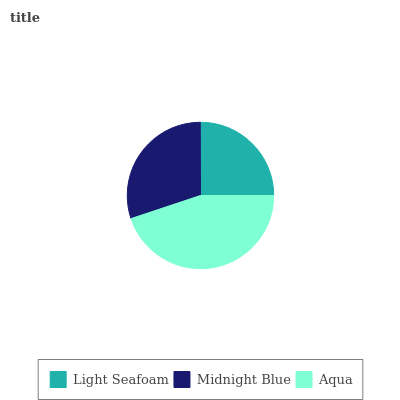Is Light Seafoam the minimum?
Answer yes or no. Yes. Is Aqua the maximum?
Answer yes or no. Yes. Is Midnight Blue the minimum?
Answer yes or no. No. Is Midnight Blue the maximum?
Answer yes or no. No. Is Midnight Blue greater than Light Seafoam?
Answer yes or no. Yes. Is Light Seafoam less than Midnight Blue?
Answer yes or no. Yes. Is Light Seafoam greater than Midnight Blue?
Answer yes or no. No. Is Midnight Blue less than Light Seafoam?
Answer yes or no. No. Is Midnight Blue the high median?
Answer yes or no. Yes. Is Midnight Blue the low median?
Answer yes or no. Yes. Is Aqua the high median?
Answer yes or no. No. Is Aqua the low median?
Answer yes or no. No. 